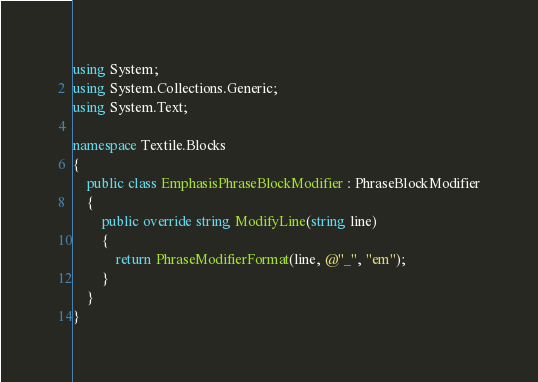Convert code to text. <code><loc_0><loc_0><loc_500><loc_500><_C#_>using System;
using System.Collections.Generic;
using System.Text;

namespace Textile.Blocks
{
    public class EmphasisPhraseBlockModifier : PhraseBlockModifier
    {
        public override string ModifyLine(string line)
        {
            return PhraseModifierFormat(line, @"_", "em");
        }
    }
}
</code> 